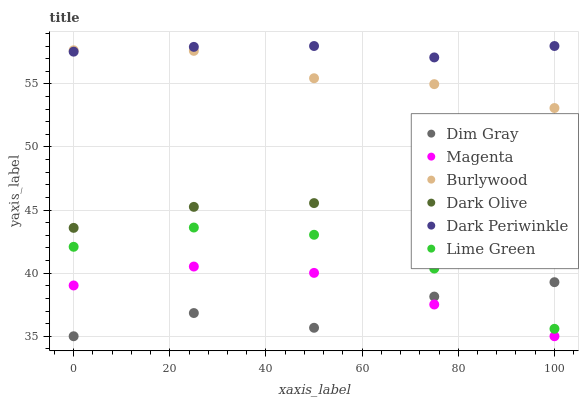Does Dim Gray have the minimum area under the curve?
Answer yes or no. Yes. Does Dark Periwinkle have the maximum area under the curve?
Answer yes or no. Yes. Does Burlywood have the minimum area under the curve?
Answer yes or no. No. Does Burlywood have the maximum area under the curve?
Answer yes or no. No. Is Dark Periwinkle the smoothest?
Answer yes or no. Yes. Is Dim Gray the roughest?
Answer yes or no. Yes. Is Burlywood the smoothest?
Answer yes or no. No. Is Burlywood the roughest?
Answer yes or no. No. Does Dim Gray have the lowest value?
Answer yes or no. Yes. Does Burlywood have the lowest value?
Answer yes or no. No. Does Dark Periwinkle have the highest value?
Answer yes or no. Yes. Does Burlywood have the highest value?
Answer yes or no. No. Is Magenta less than Dark Periwinkle?
Answer yes or no. Yes. Is Burlywood greater than Dark Olive?
Answer yes or no. Yes. Does Dim Gray intersect Magenta?
Answer yes or no. Yes. Is Dim Gray less than Magenta?
Answer yes or no. No. Is Dim Gray greater than Magenta?
Answer yes or no. No. Does Magenta intersect Dark Periwinkle?
Answer yes or no. No. 